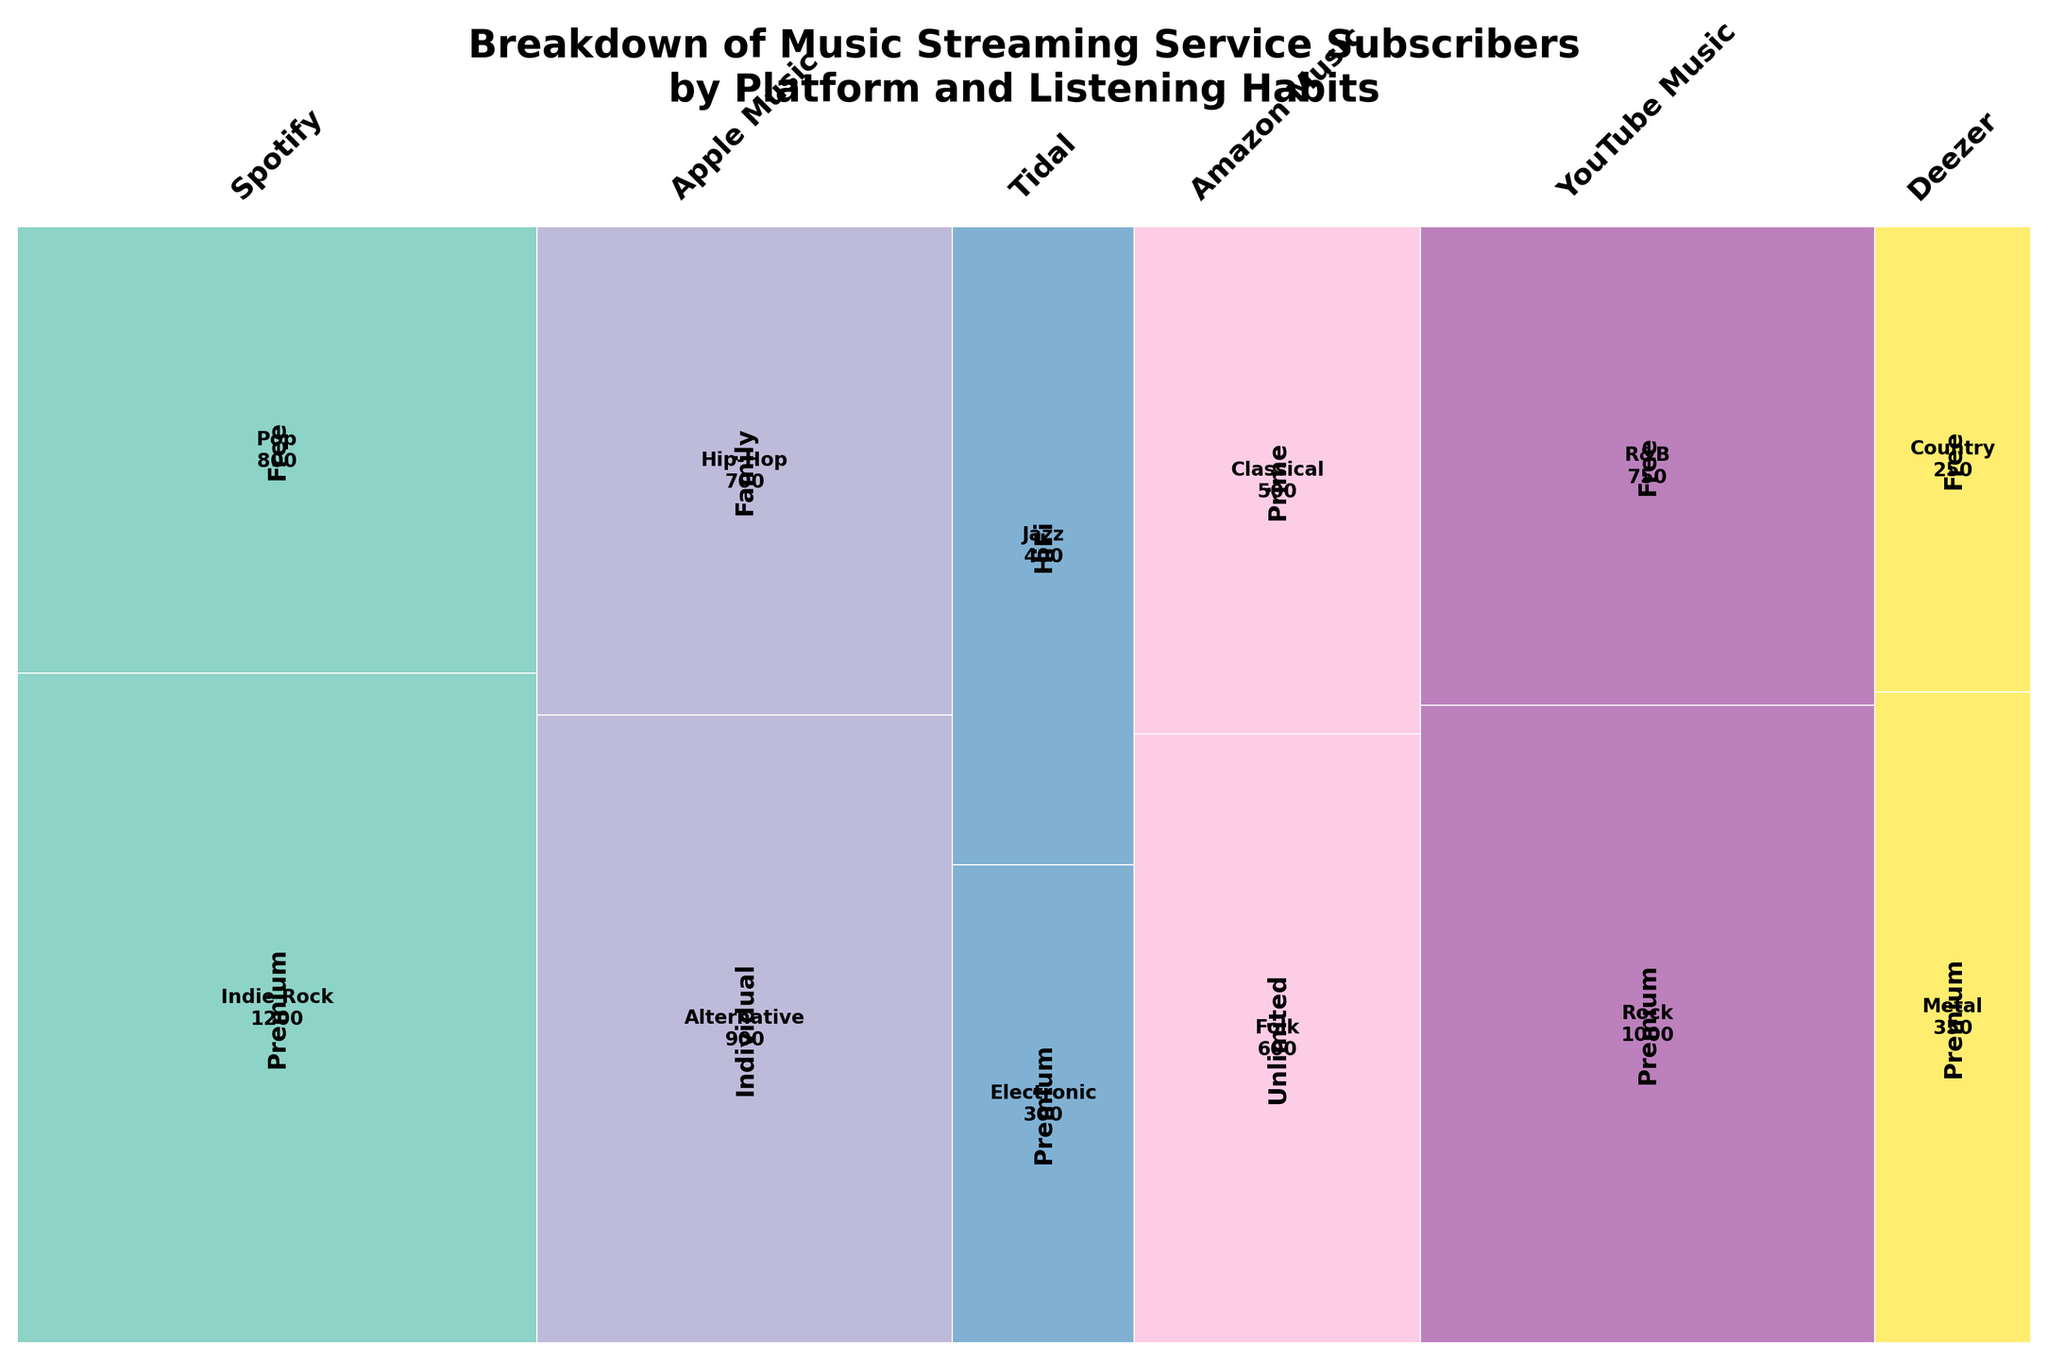Which platform has the highest number of subscribers? To determine the platform with the highest number of subscribers, look for the widest bars in the mosaic plot as they represent the relative proportions of total subscribers for each platform. The platform with the widest bar has the highest total count.
Answer: Spotify How many subscribers listen to Pop on Spotify's free tier? Identify the section of the mosaic plot corresponding to Spotify's free tier (this is usually visually separated by different labels or shading), then look for the segment within this section labeled as Pop. The number within this segment indicates the count of subscribers.
Answer: 800 What listening habit is most popular among YouTube Music's premium subscribers? Locate the segment of the mosaic plot representing YouTube Music's premium subscribers, then identify which listening habit segment within this area is the largest. The label within this segment indicates the most popular listening habit.
Answer: Rock Comparing Spotify and Apple Music, which has more premium subscribers? Compare the width of the segments representing Spotify's Premium subscribers and Apple Music's Individual subscribers. The segment with greater width corresponds to the platform with more premium subscribers.
Answer: Spotify Which platform has the least number of subscribers listening to Jazz? Locate all the segments labeled as Jazz across different platforms in the mosaic plot, then compare their sizes. The smallest segment indicates the platform with the least number of Jazz listeners.
Answer: Tidal What are the total subscribers for Tidal? Sum the counts of all segments under Tidal. Tidal has two segments - HiFi and Premium subscribers. Add the counts together for the total.
Answer: 400 (HiFi) + 300 (Premium) = 700 How many more subscribers listen to Indie Rock on Spotify premium than Country on Deezer free? Reference the counts in the segments for Indie Rock on Spotify premium and Country on Deezer free, then calculate the difference between these counts.
Answer: 1200 - 250 = 950 Which platform has a larger proportion of its subscribers listening to folk music, Amazon Music or Tidal? Find the folk music segments within Amazon Music and Tidal. Then, compare their relative sizes within their respective platform sections.
Answer: Amazon Music Do more subscribers listen to Classical on Amazon Music Prime or Electronic on Tidal Premium? Compare the sizes of the segments labeled Classical under Amazon Music Prime with the Electronic under Tidal Premium. The larger segment indicates more subscribers.
Answer: Amazon Music Prime (Classical) 